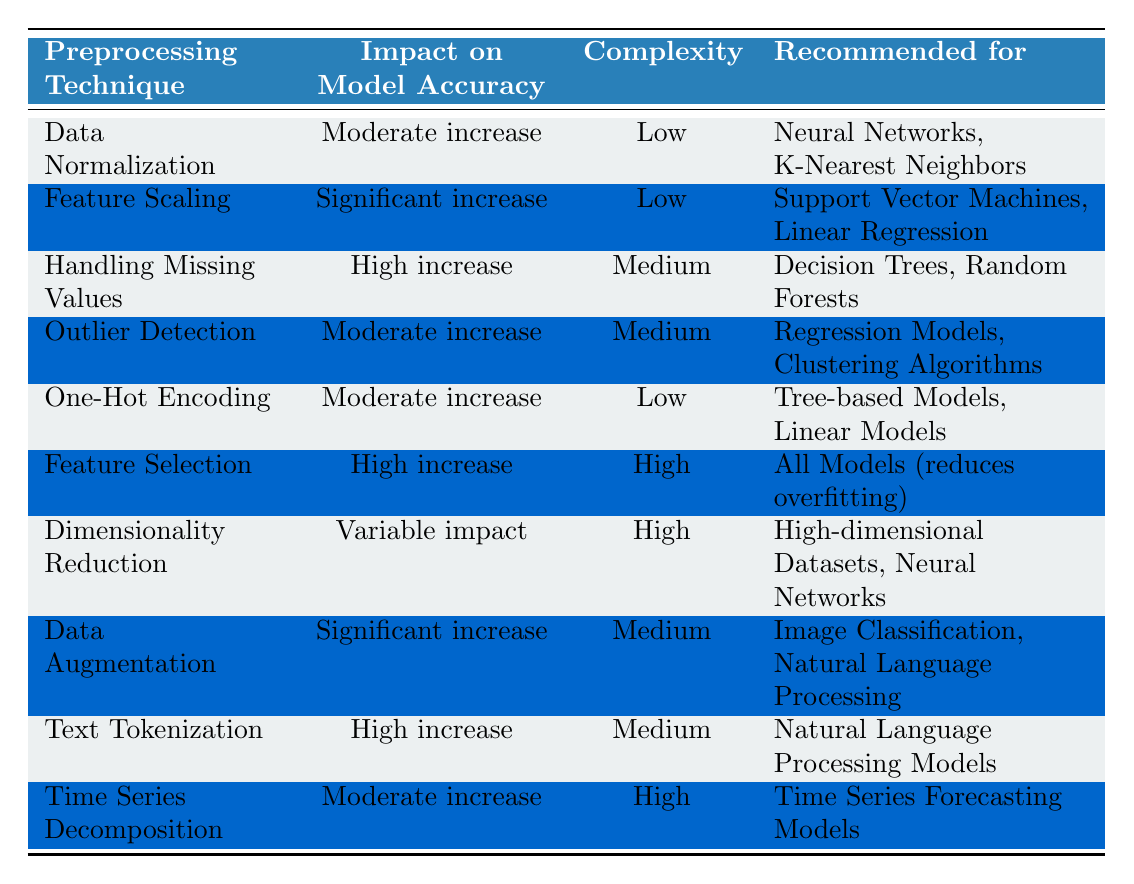What is the impact on model accuracy for Data Normalization? The table shows that Data Normalization has a "Moderate increase" in impact on model accuracy.
Answer: Moderate increase Which preprocessing technique is recommended for Decision Trees? The table indicates that Handling Missing Values is recommended for Decision Trees, and it has a "High increase" in model accuracy.
Answer: Handling Missing Values Is Feature Selection recommended for all models? Yes, the table states that Feature Selection is recommended for all models and it significantly helps in reducing overfitting.
Answer: Yes What preprocessing technique has the highest complexity level? Two techniques have high complexity: Feature Selection and Dimensionality Reduction. The former shows a high increase in model accuracy while the latter has variable impact.
Answer: Feature Selection and Dimensionality Reduction How does Data Augmentation's impact compare to One-Hot Encoding? The impact of Data Augmentation is a "Significant increase," while One-Hot Encoding has a "Moderate increase." This indicates that Data Augmentation has a greater positive impact on model accuracy than One-Hot Encoding.
Answer: Data Augmentation has a greater impact 